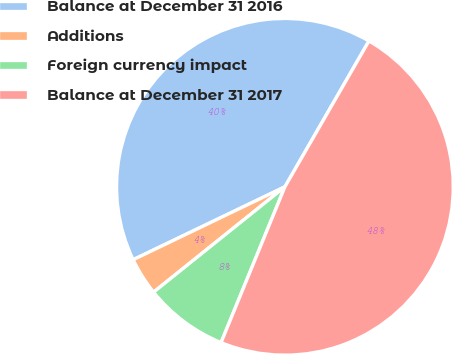Convert chart to OTSL. <chart><loc_0><loc_0><loc_500><loc_500><pie_chart><fcel>Balance at December 31 2016<fcel>Additions<fcel>Foreign currency impact<fcel>Balance at December 31 2017<nl><fcel>40.45%<fcel>3.63%<fcel>8.05%<fcel>47.87%<nl></chart> 